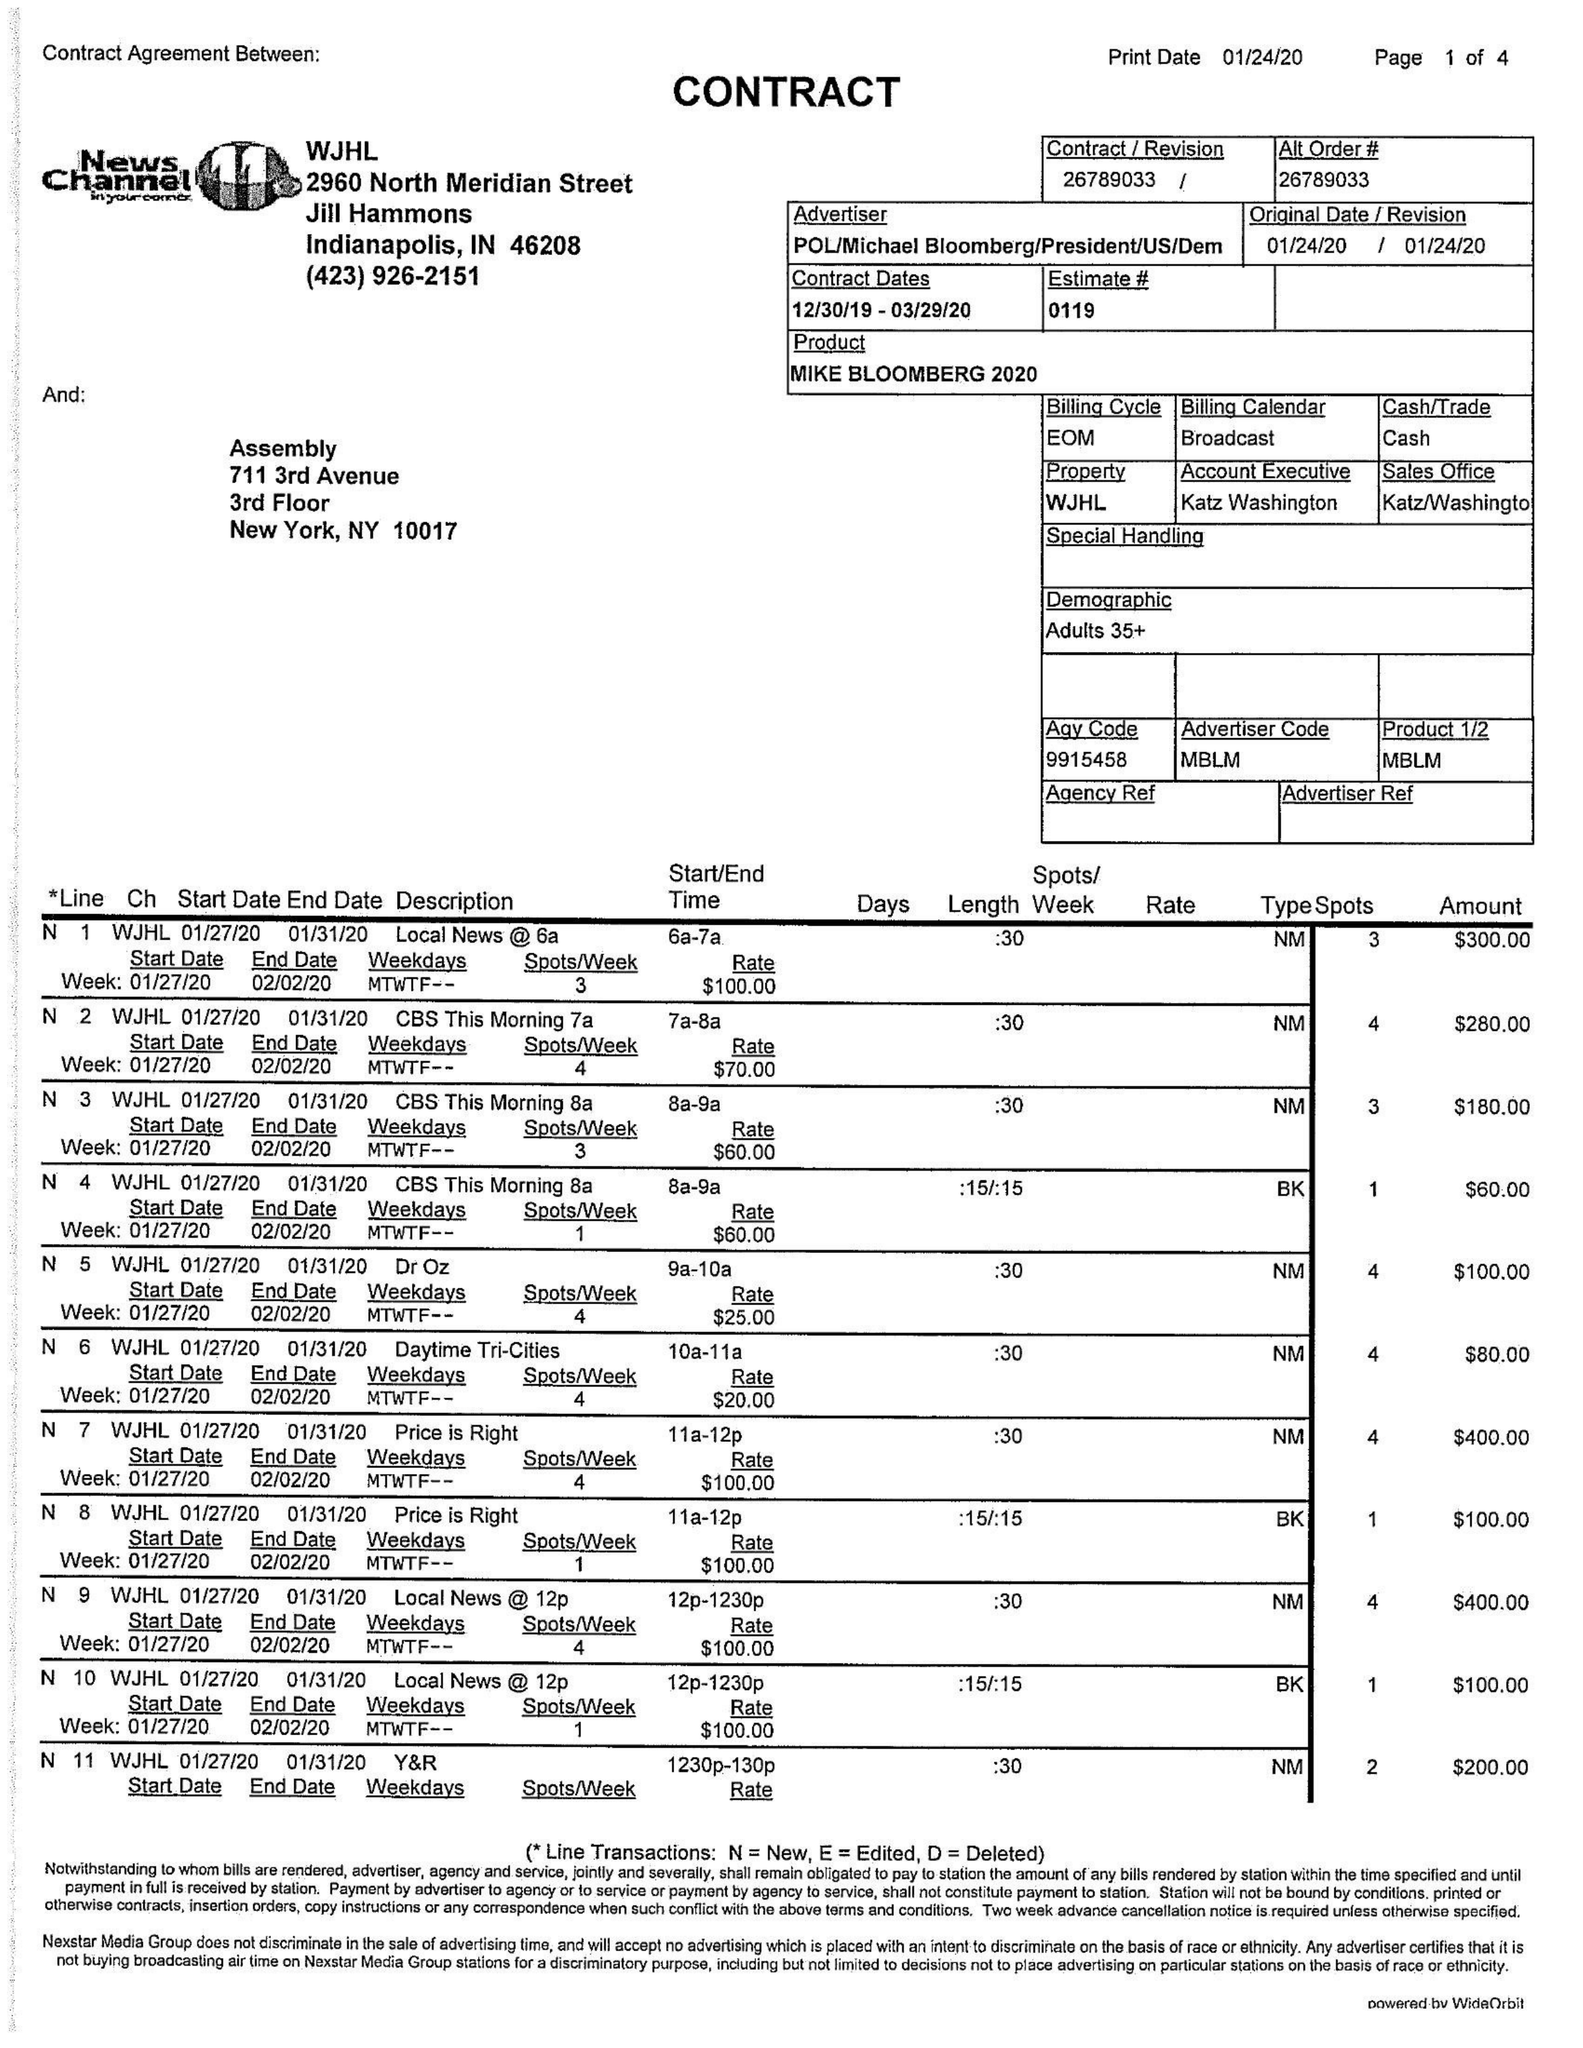What is the value for the flight_from?
Answer the question using a single word or phrase. 12/30/19 